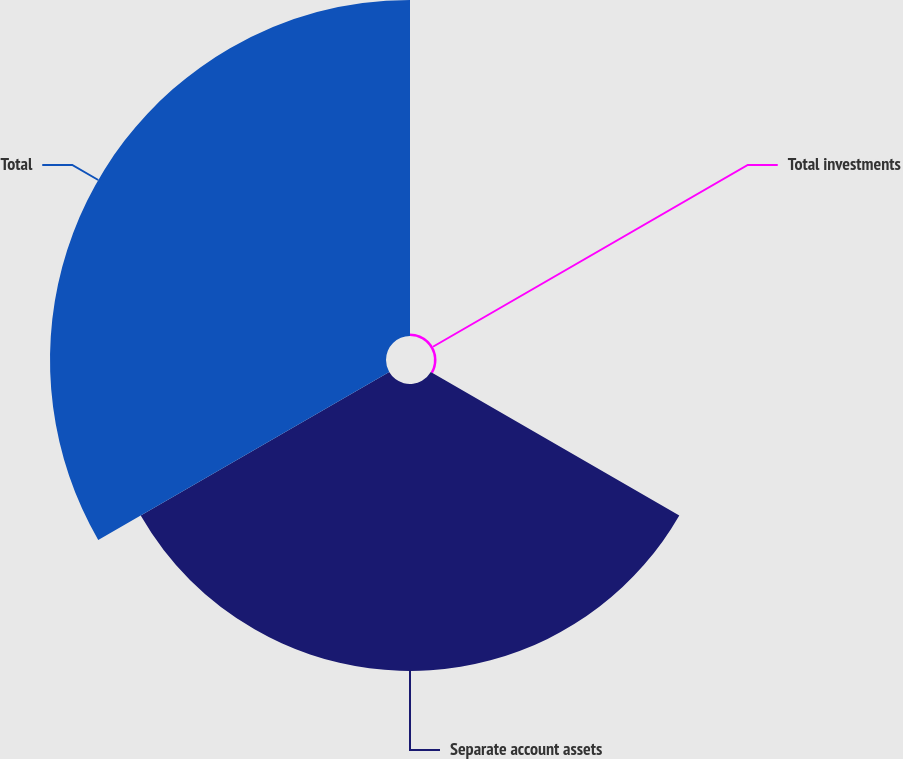Convert chart to OTSL. <chart><loc_0><loc_0><loc_500><loc_500><pie_chart><fcel>Total investments<fcel>Separate account assets<fcel>Total<nl><fcel>0.4%<fcel>45.88%<fcel>53.72%<nl></chart> 